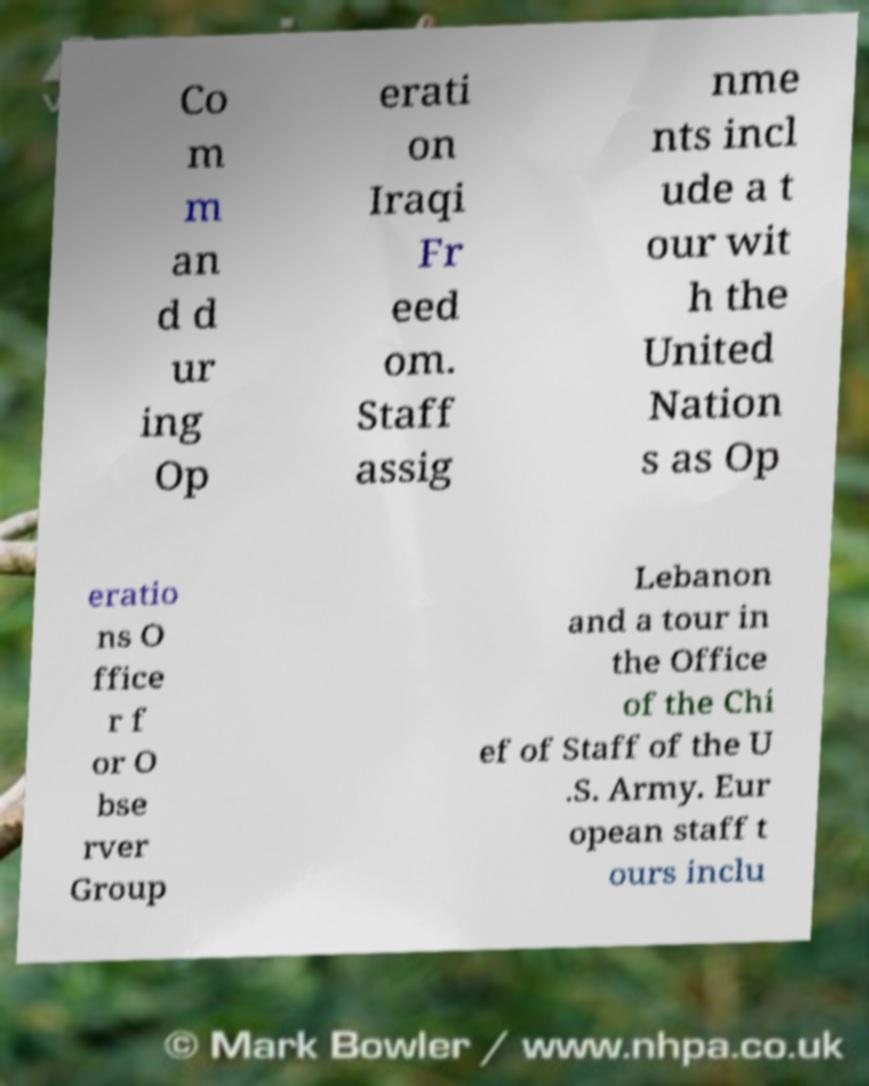Could you extract and type out the text from this image? Co m m an d d ur ing Op erati on Iraqi Fr eed om. Staff assig nme nts incl ude a t our wit h the United Nation s as Op eratio ns O ffice r f or O bse rver Group Lebanon and a tour in the Office of the Chi ef of Staff of the U .S. Army. Eur opean staff t ours inclu 